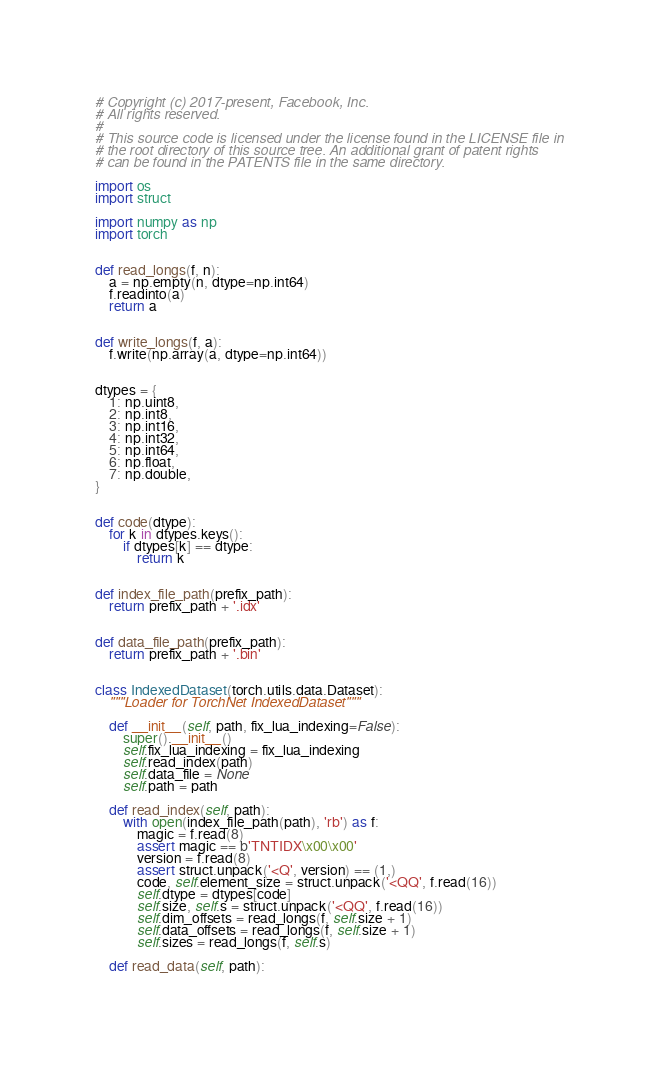<code> <loc_0><loc_0><loc_500><loc_500><_Python_># Copyright (c) 2017-present, Facebook, Inc.
# All rights reserved.
#
# This source code is licensed under the license found in the LICENSE file in
# the root directory of this source tree. An additional grant of patent rights
# can be found in the PATENTS file in the same directory.

import os
import struct

import numpy as np
import torch


def read_longs(f, n):
    a = np.empty(n, dtype=np.int64)
    f.readinto(a)
    return a


def write_longs(f, a):
    f.write(np.array(a, dtype=np.int64))


dtypes = {
    1: np.uint8,
    2: np.int8,
    3: np.int16,
    4: np.int32,
    5: np.int64,
    6: np.float,
    7: np.double,
}


def code(dtype):
    for k in dtypes.keys():
        if dtypes[k] == dtype:
            return k


def index_file_path(prefix_path):
    return prefix_path + '.idx'


def data_file_path(prefix_path):
    return prefix_path + '.bin'


class IndexedDataset(torch.utils.data.Dataset):
    """Loader for TorchNet IndexedDataset"""

    def __init__(self, path, fix_lua_indexing=False):
        super().__init__()
        self.fix_lua_indexing = fix_lua_indexing
        self.read_index(path)
        self.data_file = None
        self.path = path

    def read_index(self, path):
        with open(index_file_path(path), 'rb') as f:
            magic = f.read(8)
            assert magic == b'TNTIDX\x00\x00'
            version = f.read(8)
            assert struct.unpack('<Q', version) == (1,)
            code, self.element_size = struct.unpack('<QQ', f.read(16))
            self.dtype = dtypes[code]
            self.size, self.s = struct.unpack('<QQ', f.read(16))
            self.dim_offsets = read_longs(f, self.size + 1)
            self.data_offsets = read_longs(f, self.size + 1)
            self.sizes = read_longs(f, self.s)

    def read_data(self, path):</code> 